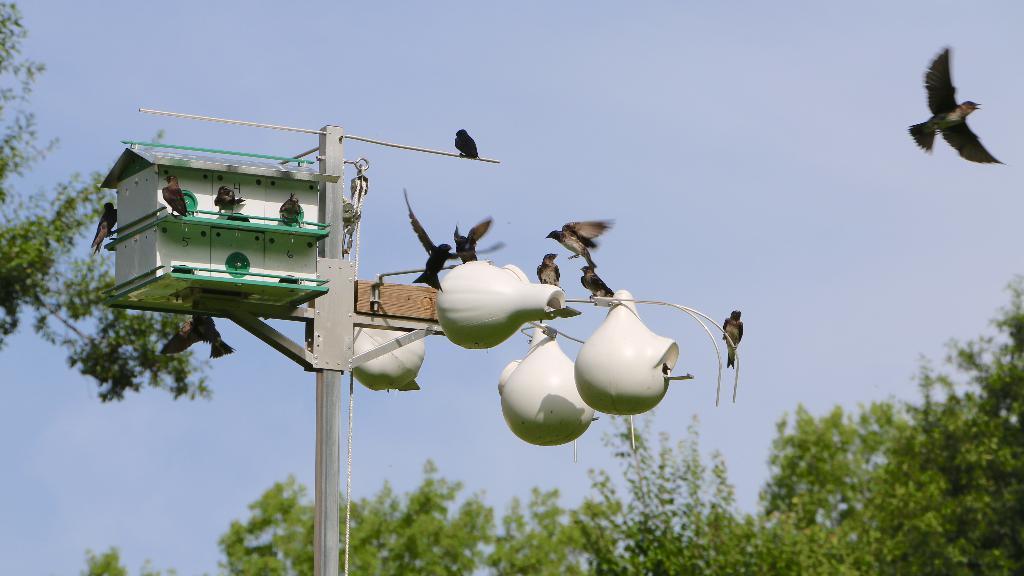Could you give a brief overview of what you see in this image? In this image we can see a birdhouse on a stand. There are many birds flying. Some are sitting on that. In the background there are trees and sky. 